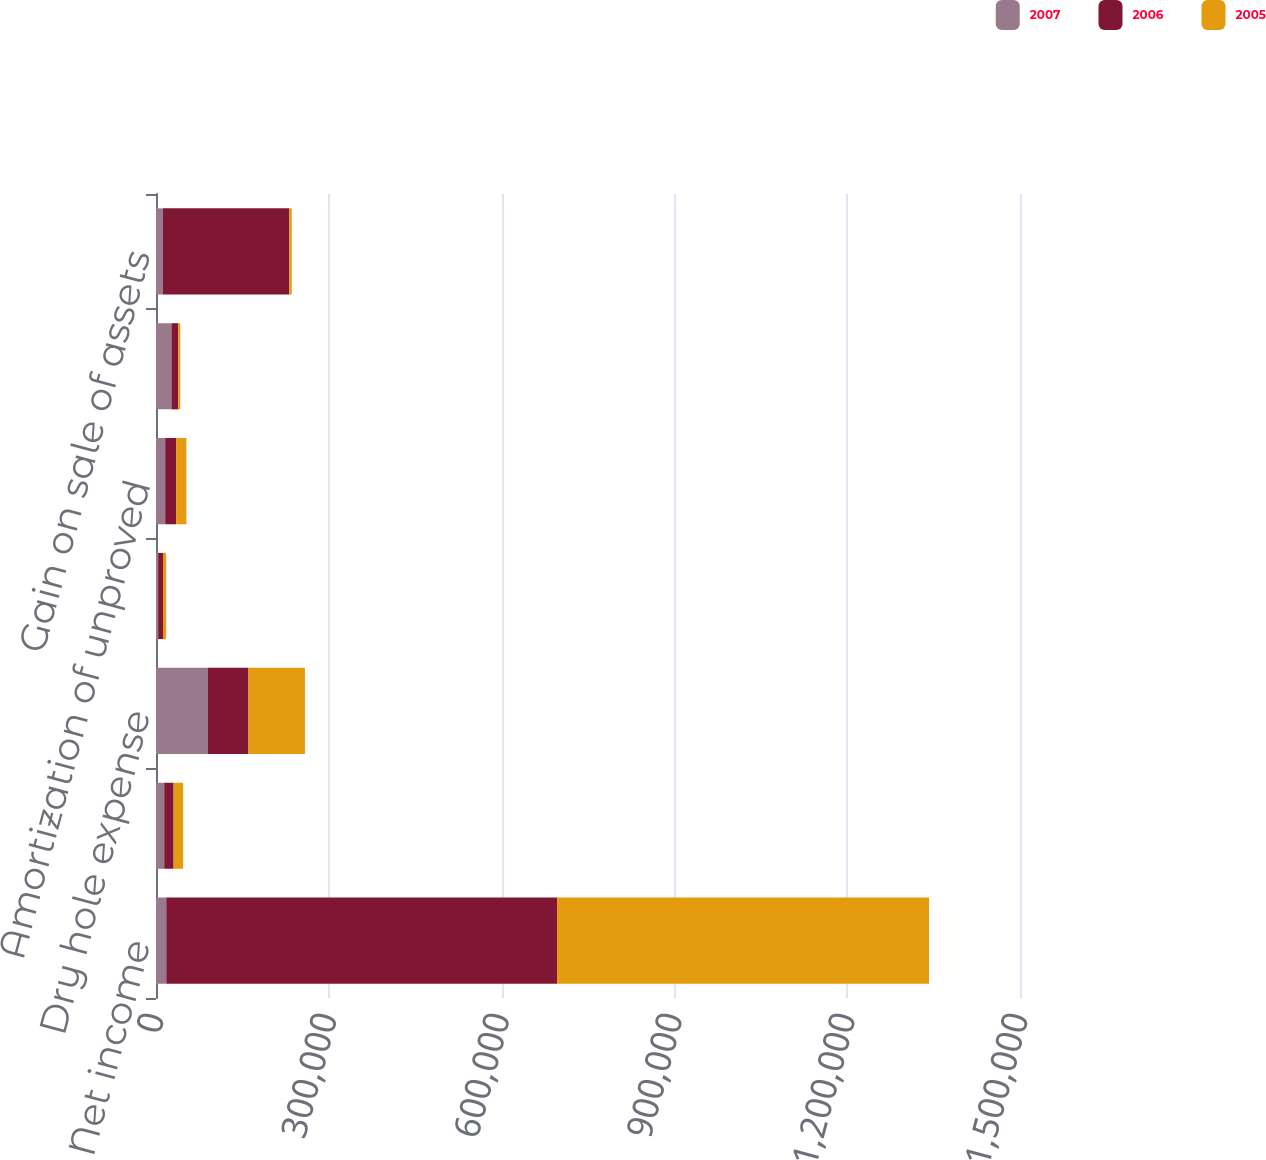Convert chart. <chart><loc_0><loc_0><loc_500><loc_500><stacked_bar_chart><ecel><fcel>Net income<fcel>Depreciation depletion and<fcel>Dry hole expense<fcel>Impairment of operating assets<fcel>Amortization of unproved<fcel>Stock-based compensation<fcel>Gain on sale of assets<nl><fcel>2007<fcel>17855<fcel>14277<fcel>90210<fcel>3661<fcel>16013<fcel>26825<fcel>11854<nl><fcel>2006<fcel>678428<fcel>16319<fcel>70325<fcel>8525<fcel>18923<fcel>11816<fcel>219577<nl><fcel>2005<fcel>645720<fcel>16476<fcel>98015<fcel>5368<fcel>17855<fcel>3467<fcel>4201<nl></chart> 